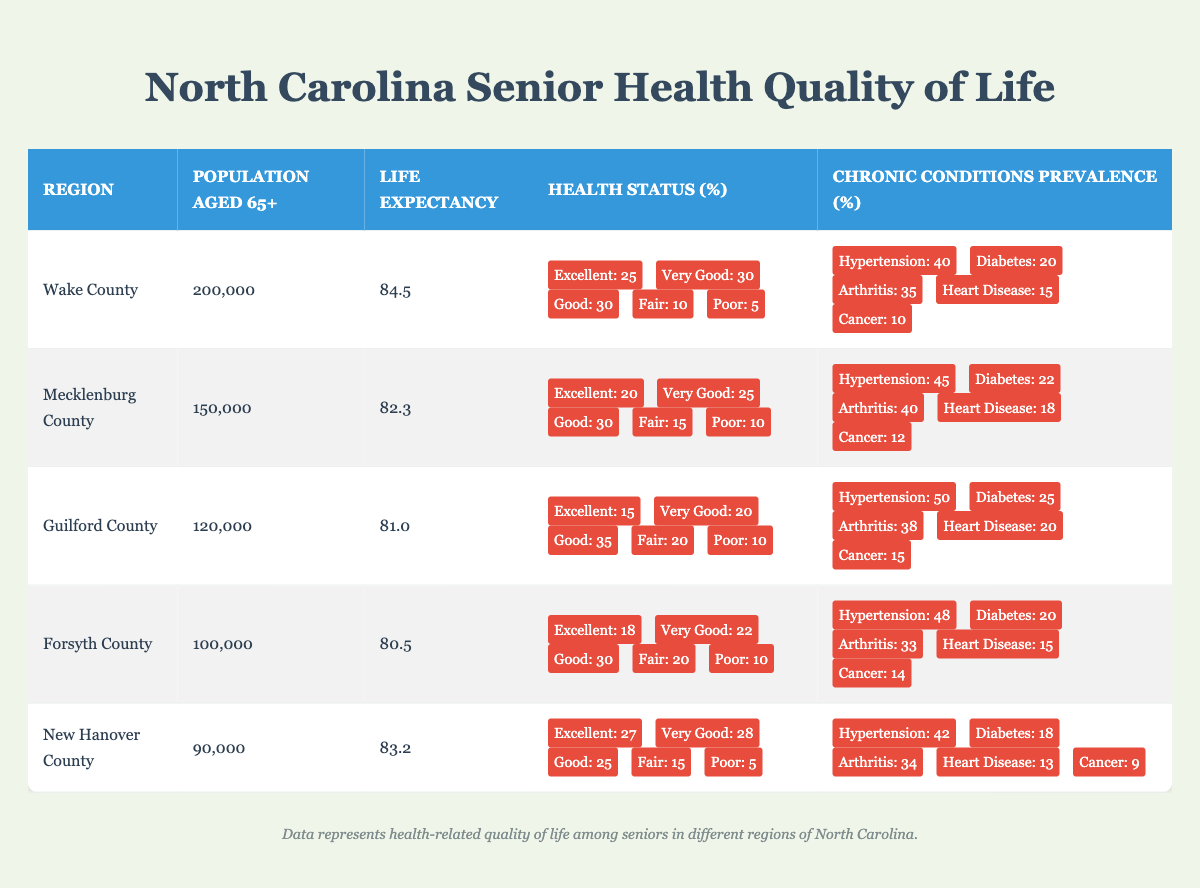What is the population aged 65+ in Wake County? The table shows the population aged 65+ for each region. For Wake County, the population is specifically listed as 200,000.
Answer: 200,000 Which region has the highest life expectancy? By examining the "Life Expectancy" column, Wake County has the highest value at 84.5 years, which is greater than the other regions listed.
Answer: Wake County What percentage of seniors in Guilford County have an excellent health status? The table indicates that 15% of the population aged 65+ in Guilford County report their health status as excellent, as seen in the "Health Status" row for that region.
Answer: 15% If we add up the percentages of those reporting their health as excellent and very good in New Hanover County, what do we get? For New Hanover County, the percentages for excellent and very good health are 27% and 28% respectively. Adding these gives us 27 + 28 = 55%.
Answer: 55% Is it true that Forsyth County has a higher percentage of residents reporting fair health status compared to Mecklenburg County? In Forsyth County, the fair health status percentage is 20%, while in Mecklenburg County it is 15%. Since 20% is greater than 15%, the statement is true.
Answer: Yes Among the chronic conditions, which region has the highest prevalence of hypertension? The data shows that Guilford County has the highest prevalence of hypertension at 50%, which is higher than the figures for Wake County, Mecklenburg County, Forsyth County, and New Hanover County.
Answer: Guilford County What is the average life expectancy of seniors across all the listed counties? Adding the life expectancies: 84.5 (Wake) + 82.3 (Mecklenburg) + 81.0 (Guilford) + 80.5 (Forsyth) + 83.2 (New Hanover) = 411.5. There are 5 regions, so the average life expectancy is 411.5 / 5 = 82.3.
Answer: 82.3 How many counties have a population aged 65+ greater than 100,000? According to the table, the counties with populations greater than 100,000 are Wake County (200,000), Mecklenburg County (150,000), and Guilford County (120,000), making a total of three counties.
Answer: 3 In Forsyth County, how much higher is the percentage of seniors with a chronic condition of diabetes compared to New Hanover County? Forsyth County has a diabetes prevalence of 20% while New Hanover County has 18%. The difference is 20 - 18 = 2%.
Answer: 2% 